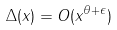<formula> <loc_0><loc_0><loc_500><loc_500>\Delta ( x ) = O ( x ^ { \theta + \epsilon } )</formula> 